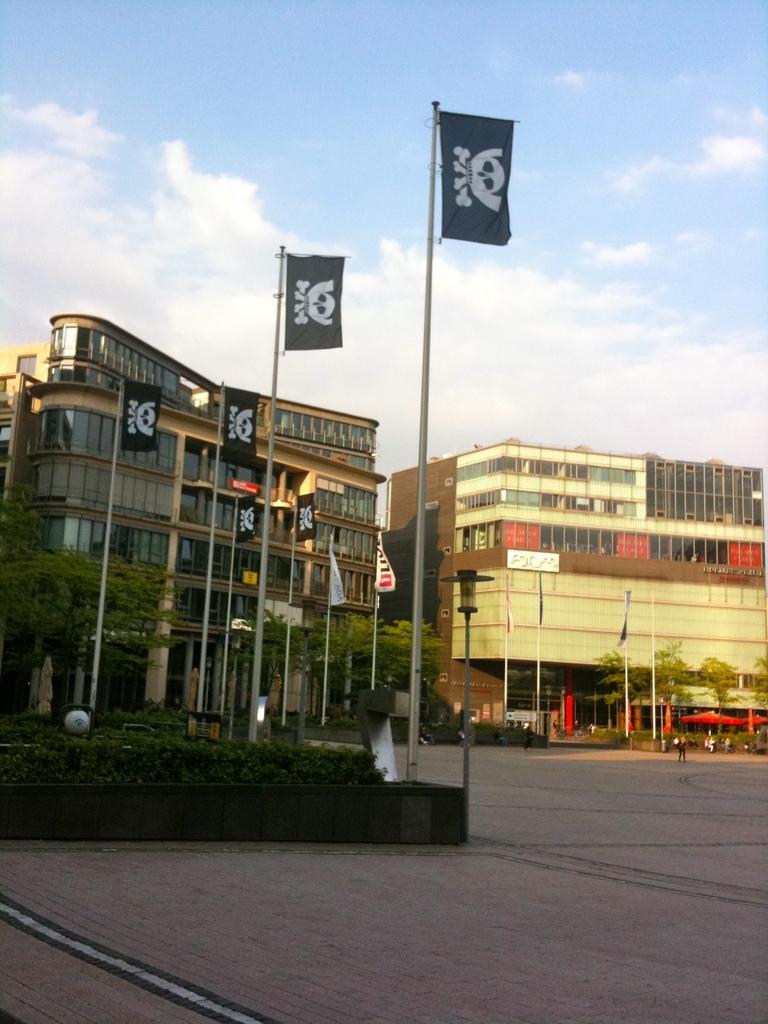Can you describe this image briefly? In this image we can see the road. And we can see the buildings. And we can see the flags and the people. And we can see the windows. And we can see the lights. And we can see the clouds in the sky. 